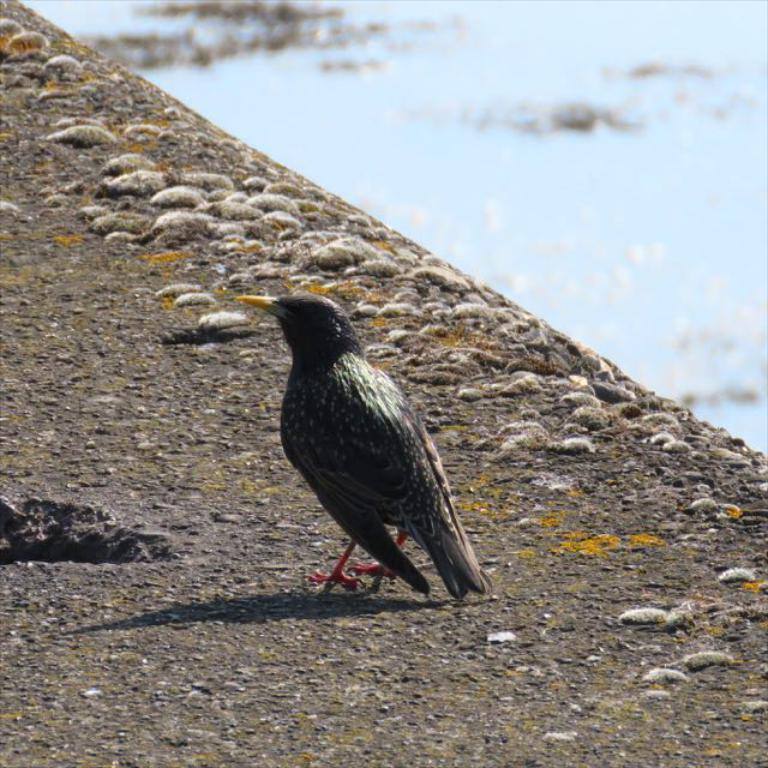What type of animal is on the ground in the image? There is a bird on the ground in the image. What else can be seen on the ground besides the bird? There are objects on the ground that look like stones. What is visible in the image besides the bird and stones? There is water visible in the image. What type of seed is the bird holding in its feet in the image? There is no seed visible in the image, nor is the bird holding anything in its feet. 